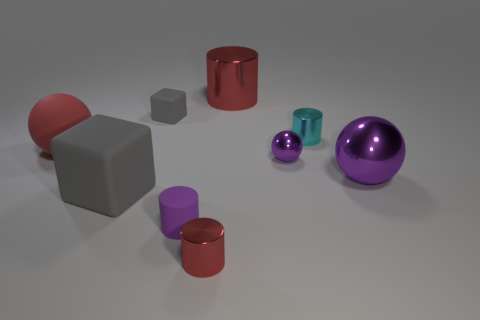Subtract all large cylinders. How many cylinders are left? 3 Add 1 red balls. How many objects exist? 10 Subtract all cyan cylinders. How many purple balls are left? 2 Subtract all purple balls. How many balls are left? 1 Subtract 4 cylinders. How many cylinders are left? 0 Subtract all balls. How many objects are left? 6 Subtract all blue spheres. Subtract all brown cubes. How many spheres are left? 3 Subtract 0 yellow cylinders. How many objects are left? 9 Subtract all purple rubber cylinders. Subtract all tiny green matte cubes. How many objects are left? 8 Add 6 big matte objects. How many big matte objects are left? 8 